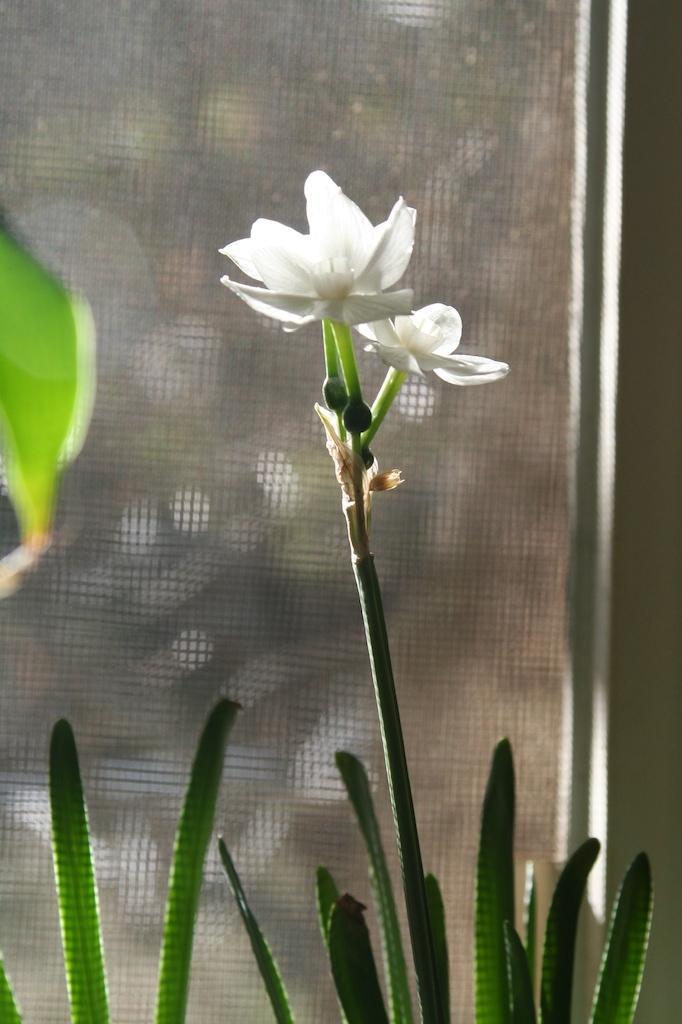Can you describe this image briefly? In this picture, in the middle, we can see a plant with white flower. On the left side, we can see a leaf. In the background, we can see a net fence, at the bottom, we can see a plant. 